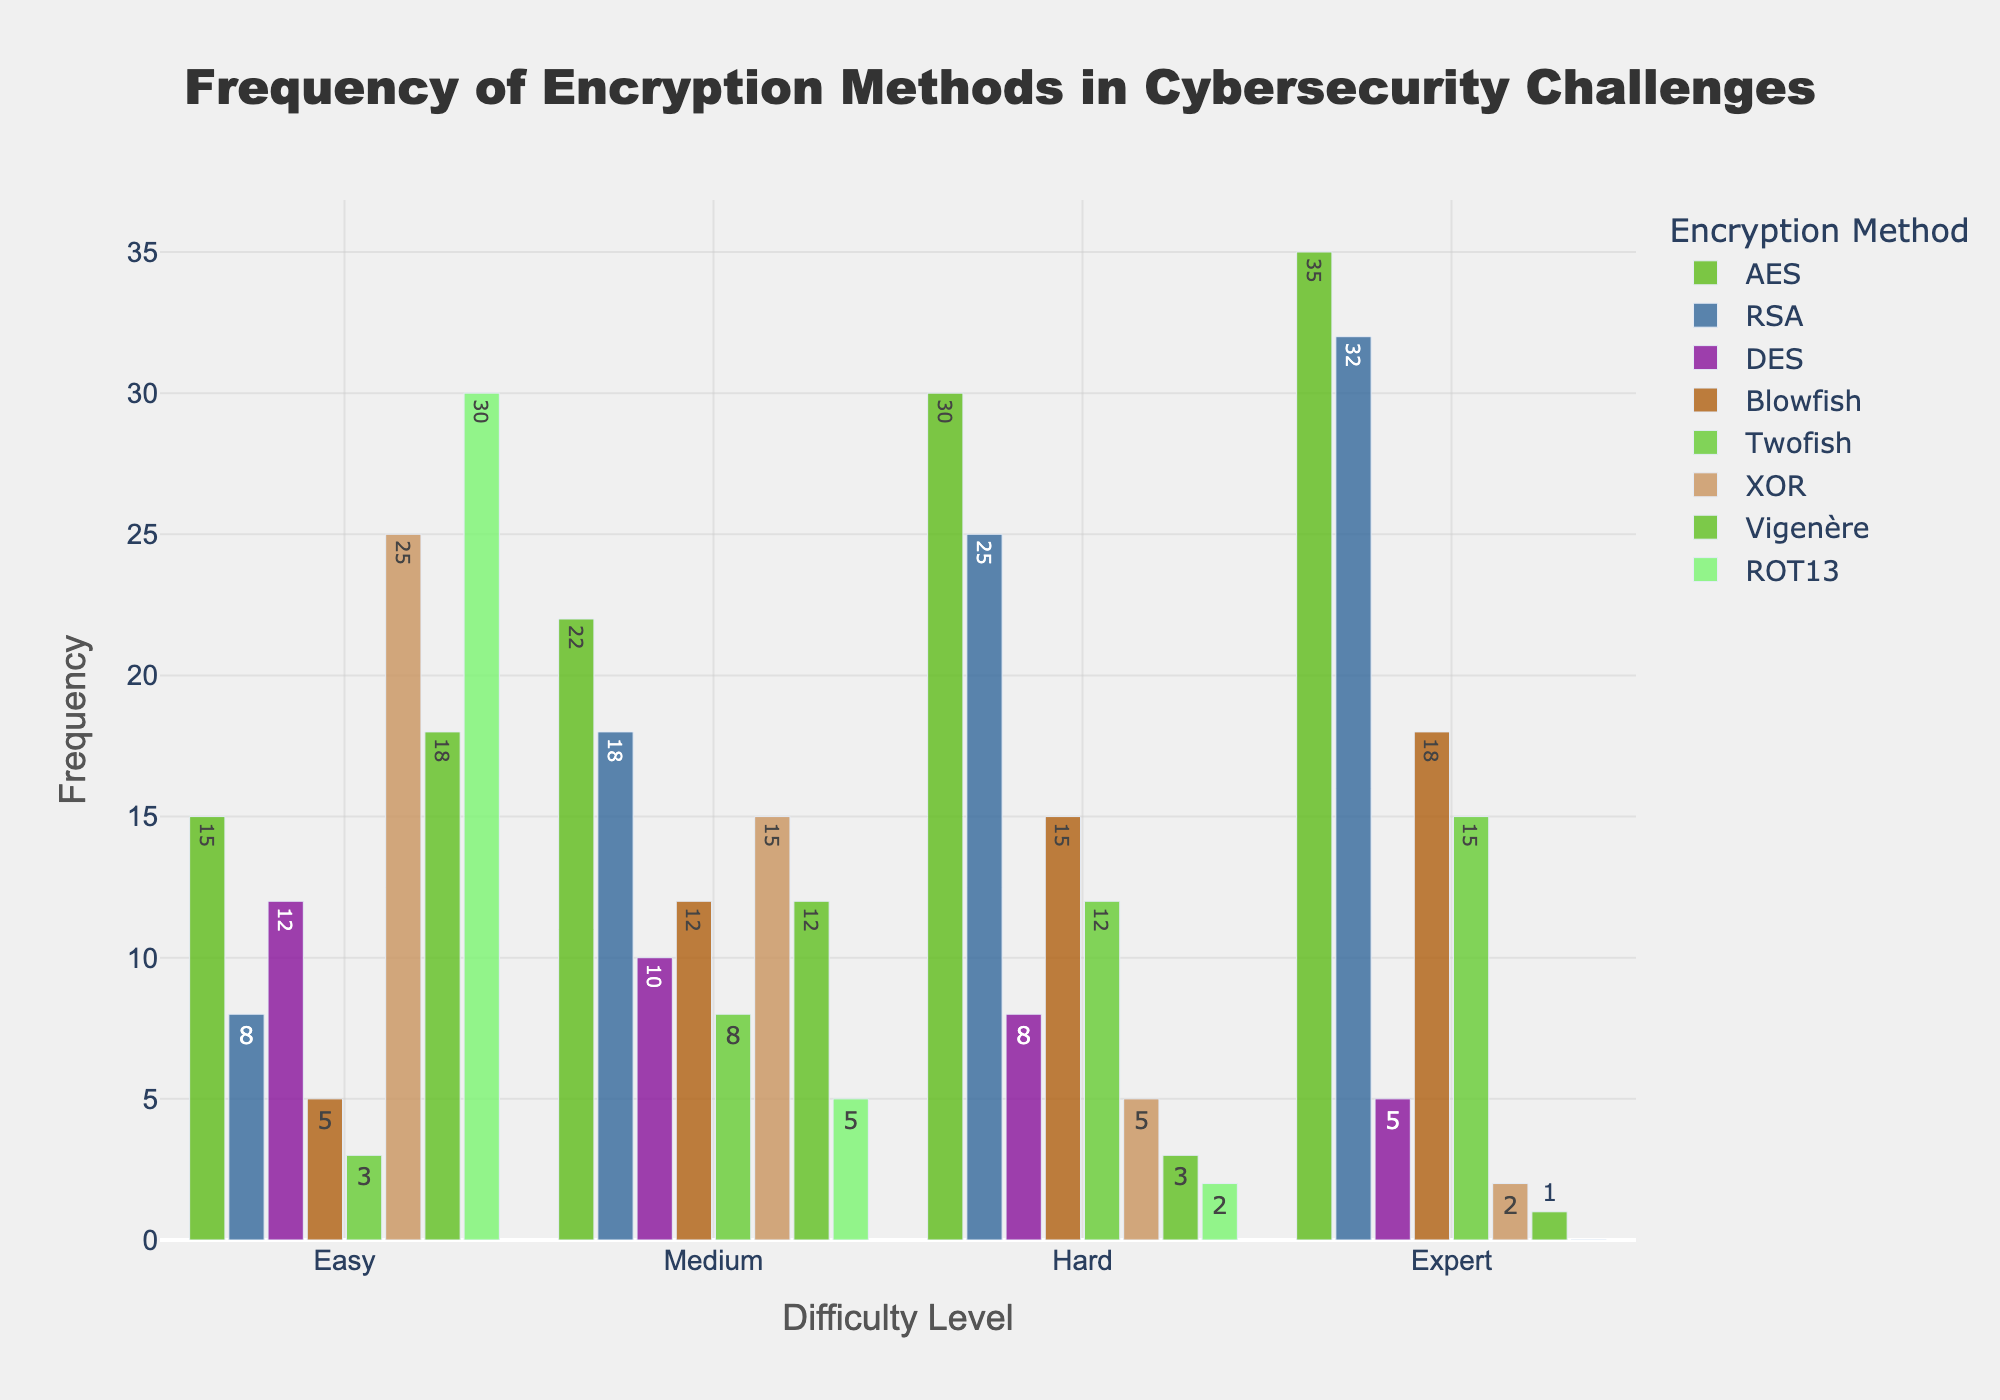What is the most frequently used encryption method for challenges at the "Expert" level? Look at the "Expert" bar section and identify the tallest bar. According to the figure, the tallest bar in the "Expert" difficulty is for the AES encryption method.
Answer: AES Which encryption method shows the highest increase in frequency from "Easy" to "Expert"? Compare the height of the bars for each encryption method between "Easy" and "Expert". The AES method increases from 15 (Easy) to 35 (Expert), which is a substantial increase.
Answer: AES How does the usage of ROT13 change as the difficulty level increases? Observe the height of the ROT13 bars across different difficulty levels. ROT13 starts highest at "Easy," then decreases steadily through "Medium," "Hard," and finally "Expert" where it's zero.
Answer: Decreases What is the difference in frequency between the most and least used methods at the "Medium" difficulty level? Identify the tallest and shortest bars in the "Medium" difficulty level. The tallest bar is for AES with a frequency of 22, and the shortest is ROT13 with a frequency of 5. The difference is 22 - 5.
Answer: 17 Which encryption method has the lowest frequency at the "Hard" level? Look at the "Hard" difficulty section and identify the shortest bar. The methods Vigenère and ROT13 have the lowest frequency bars with a frequency of 3 and 2, respectively. The lowest is ROT13.
Answer: ROT13 Is the frequency of Twofish higher than Blowfish at any difficulty level? Compare the bars for Twofish and Blowfish across all difficulty levels. Both at "Easy" and "Medium" levels, the frequency of Blowfish (5 and 12 respectively) is higher than that of Twofish (3 and 8 respectively). At "Hard" level, Blowfish (15) is higher than Twofish (12). At "Expert" level, Blowfish (18) is higher than Twofish (15).
Answer: No What is the sum of the frequencies for XOR encryption across all difficulty levels? Add the frequencies of XOR encryption for all difficulty levels: 25 (Easy) + 15 (Medium) + 5 (Hard) + 2 (Expert). The sum is 25 + 15 + 5 + 2.
Answer: 47 Which difficulty level has the highest cumulative frequency of all encryption methods combined? Sum the heights of all bars for each difficulty level. The sums are:
Easy: 15 + 8 + 12 + 5 + 3 + 25 + 18 + 30 = 116
Medium: 22 + 18 + 10 + 12 + 8 + 15 + 12 + 5 = 102
Hard: 30 + 25 + 8 + 15 + 12 + 5 + 3 + 2 = 100
Expert: 35 + 32 + 5 + 18 + 15 + 2 + 1 + 0 = 108. 
Hence, "Easy" level has the highest cumulative frequency.
Answer: Easy What is the average frequency of Vigenère for all difficulty levels? Add up the frequencies of Vigenère for each difficulty level and divide by the number of levels: (18 + 12 + 3 + 1) / 4. The sum is 34. The average is 34 / 4.
Answer: 8.5 Which difficulty level has the smallest variation in usage among different encryption methods? For each difficulty level, calculate the difference between the highest and lowest bar heights. The differences are:
Easy: 30 (ROT13) - 3 (Twofish) = 27
Medium: 22 (AES) - 5 (ROT13) = 17
Hard: 30 (AES) - 2 (ROT13) = 28
Expert: 35 (AES) - 0 (ROT13) = 35. 
The "Medium" level has the smallest variation of 17.
Answer: Medium 